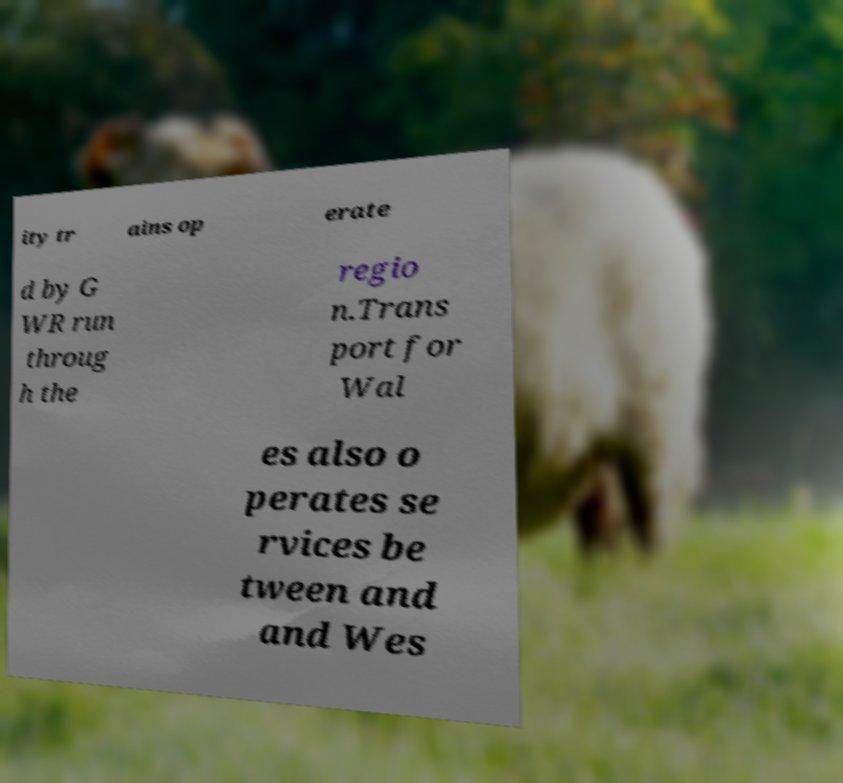Could you assist in decoding the text presented in this image and type it out clearly? ity tr ains op erate d by G WR run throug h the regio n.Trans port for Wal es also o perates se rvices be tween and and Wes 